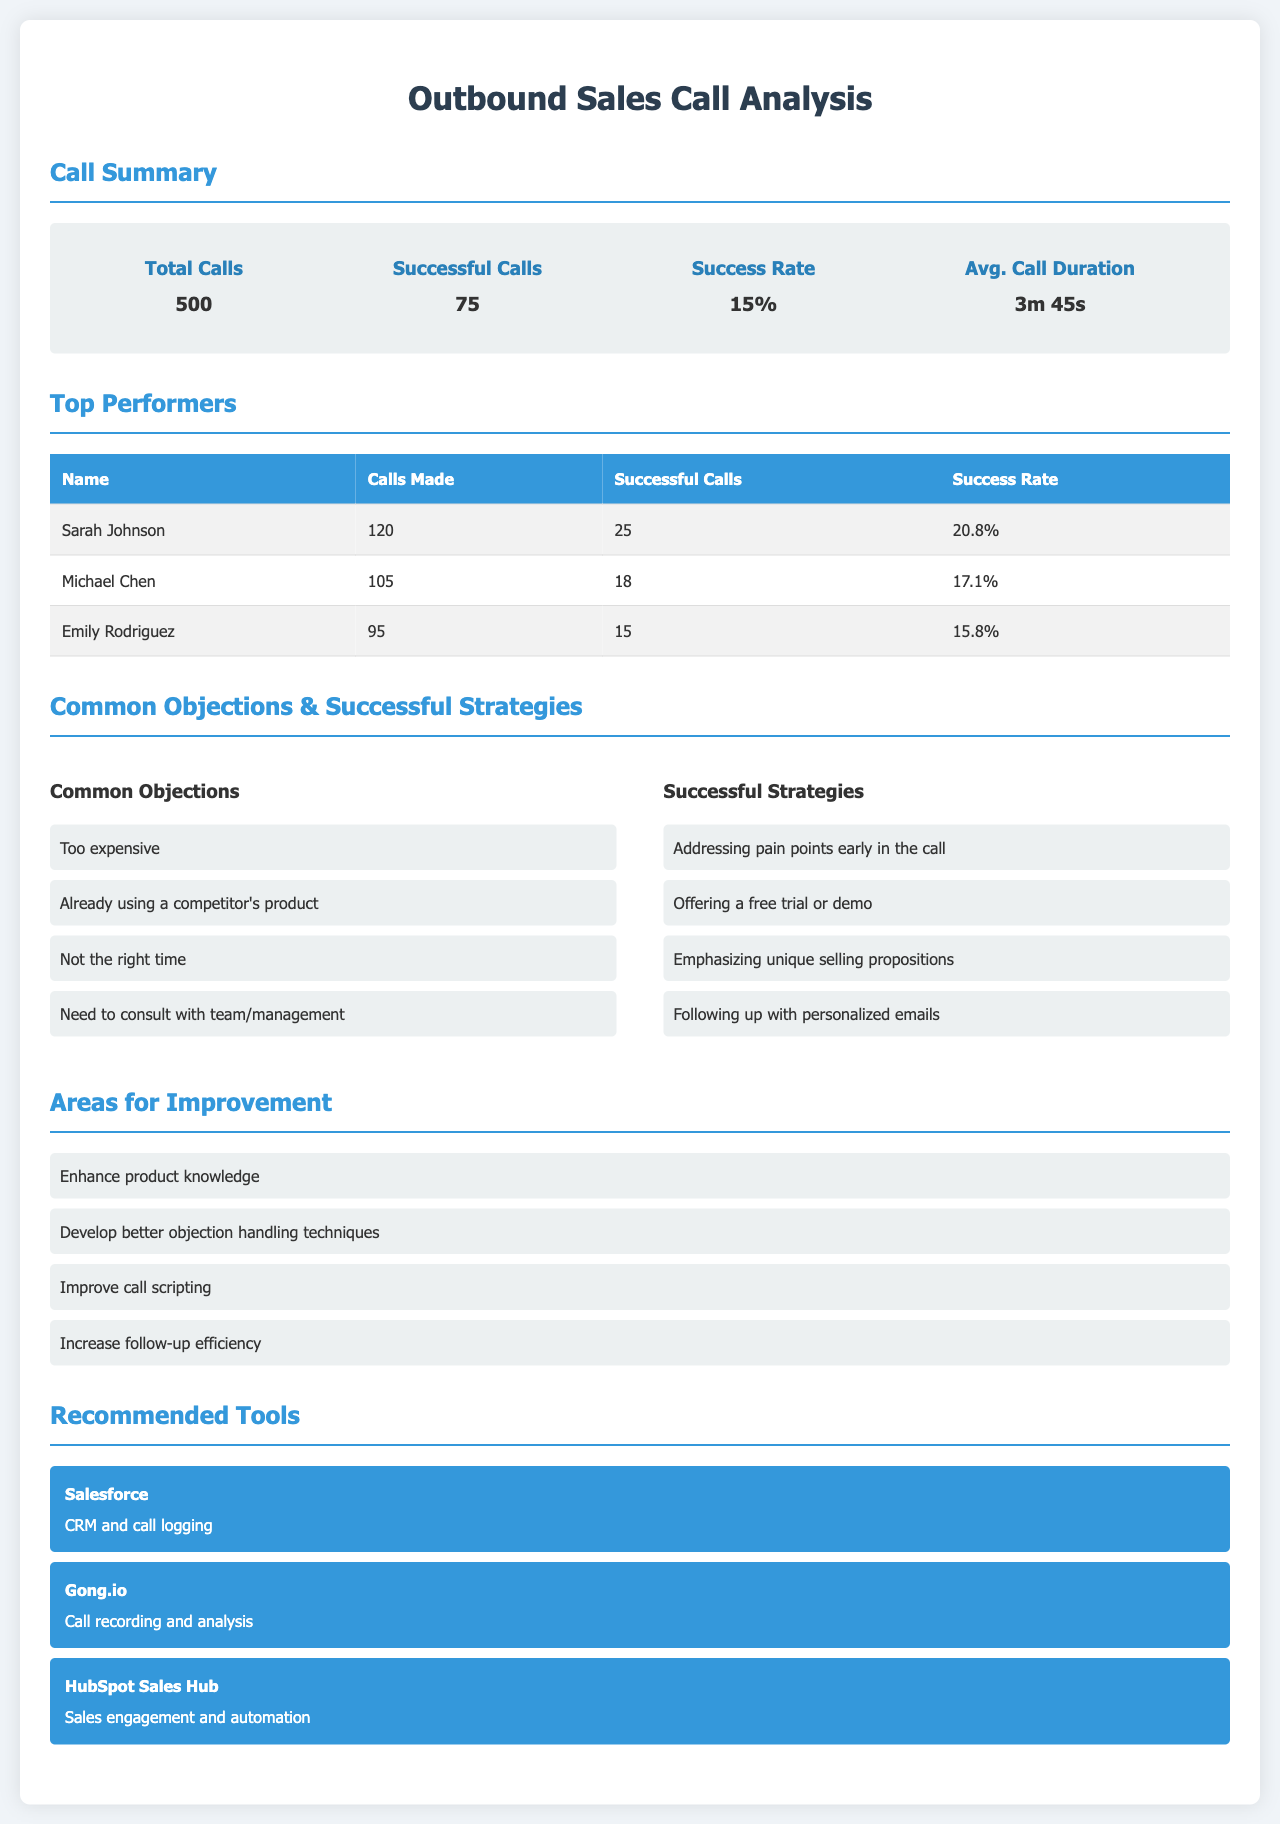What is the total number of calls? The total number of calls is clearly stated in the document under the Call Summary section.
Answer: 500 What is the success rate of the outbound calls? The success rate is defined in the document as the ratio of successful calls to total calls.
Answer: 15% Who is the top performer with the highest success rate? The success rates of team members are compared in the Top Performers table, allowing identification of the highest one.
Answer: Sarah Johnson What are the common objections mentioned? The document lists objections under a specific section, detailing what sales representatives often face.
Answer: Too expensive How many successful calls did Michael Chen make? This information is provided in the Top Performers table where each member's successful calls are noted.
Answer: 18 What area for improvement is related to product knowledge? The document includes a section on areas for improvement that specifies developing product knowledge.
Answer: Enhance product knowledge What tool is recommended for call recording and analysis? The Recommended Tools section lists specific tools, clearly indicating which one is suitable for call analysis.
Answer: Gong.io 